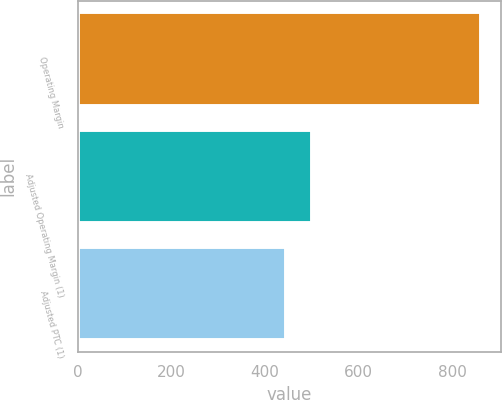Convert chart. <chart><loc_0><loc_0><loc_500><loc_500><bar_chart><fcel>Operating Margin<fcel>Adjusted Operating Margin (1)<fcel>Adjusted PTC (1)<nl><fcel>862<fcel>500<fcel>446<nl></chart> 